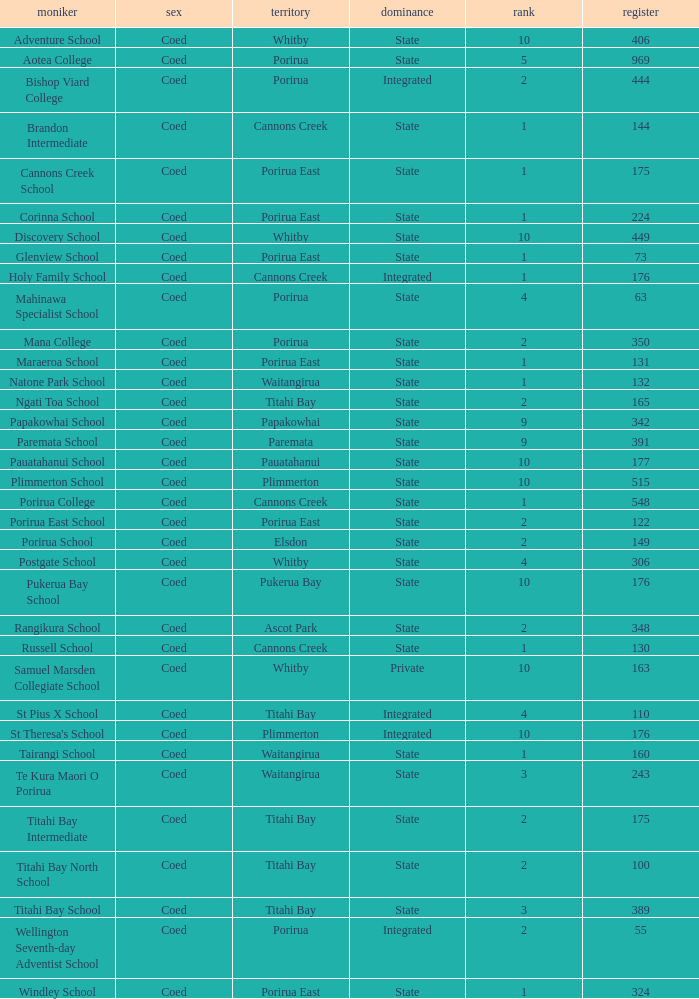What was the decile of Samuel Marsden Collegiate School in Whitby, when it had a roll higher than 163? 0.0. 